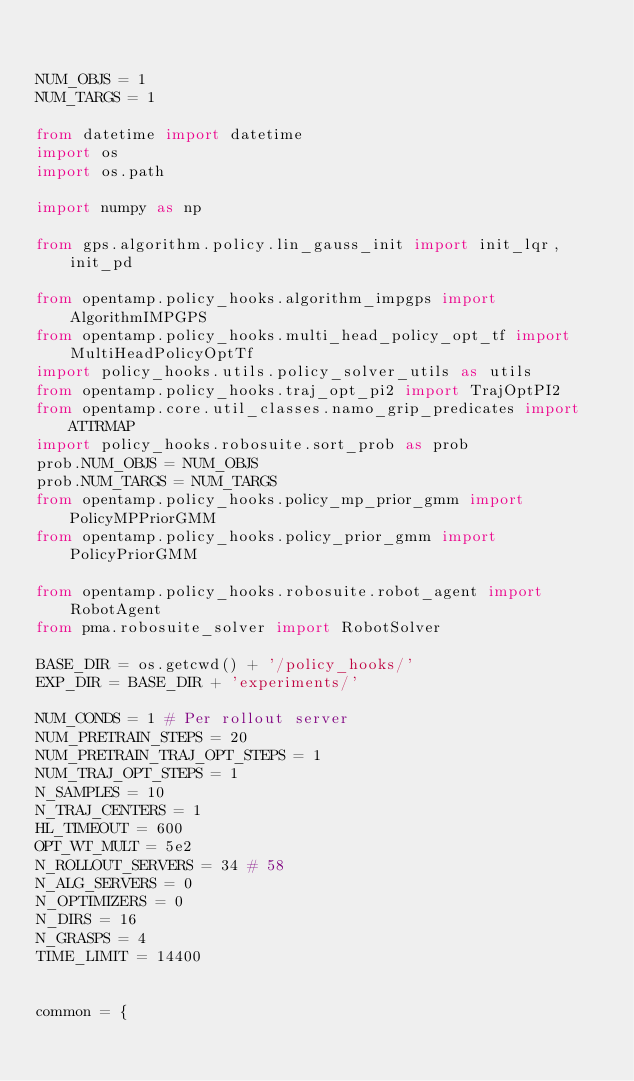<code> <loc_0><loc_0><loc_500><loc_500><_Python_>

NUM_OBJS = 1
NUM_TARGS = 1

from datetime import datetime
import os
import os.path

import numpy as np

from gps.algorithm.policy.lin_gauss_init import init_lqr, init_pd

from opentamp.policy_hooks.algorithm_impgps import AlgorithmIMPGPS
from opentamp.policy_hooks.multi_head_policy_opt_tf import MultiHeadPolicyOptTf
import policy_hooks.utils.policy_solver_utils as utils
from opentamp.policy_hooks.traj_opt_pi2 import TrajOptPI2
from opentamp.core.util_classes.namo_grip_predicates import ATTRMAP
import policy_hooks.robosuite.sort_prob as prob
prob.NUM_OBJS = NUM_OBJS
prob.NUM_TARGS = NUM_TARGS
from opentamp.policy_hooks.policy_mp_prior_gmm import PolicyMPPriorGMM
from opentamp.policy_hooks.policy_prior_gmm import PolicyPriorGMM

from opentamp.policy_hooks.robosuite.robot_agent import RobotAgent
from pma.robosuite_solver import RobotSolver

BASE_DIR = os.getcwd() + '/policy_hooks/'
EXP_DIR = BASE_DIR + 'experiments/'

NUM_CONDS = 1 # Per rollout server
NUM_PRETRAIN_STEPS = 20
NUM_PRETRAIN_TRAJ_OPT_STEPS = 1
NUM_TRAJ_OPT_STEPS = 1
N_SAMPLES = 10
N_TRAJ_CENTERS = 1
HL_TIMEOUT = 600
OPT_WT_MULT = 5e2
N_ROLLOUT_SERVERS = 34 # 58
N_ALG_SERVERS = 0
N_OPTIMIZERS = 0
N_DIRS = 16
N_GRASPS = 4
TIME_LIMIT = 14400


common = {</code> 